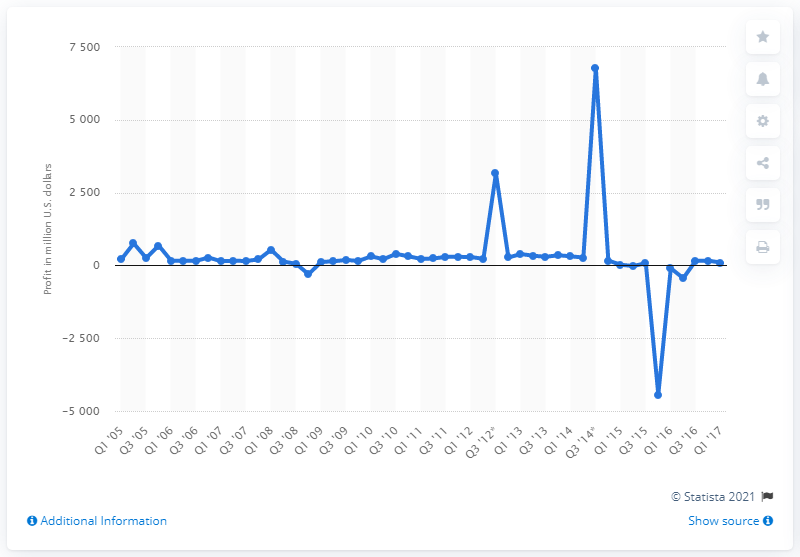Point out several critical features in this image. Yahoo's net income in the most recent quarter was $99 million. 